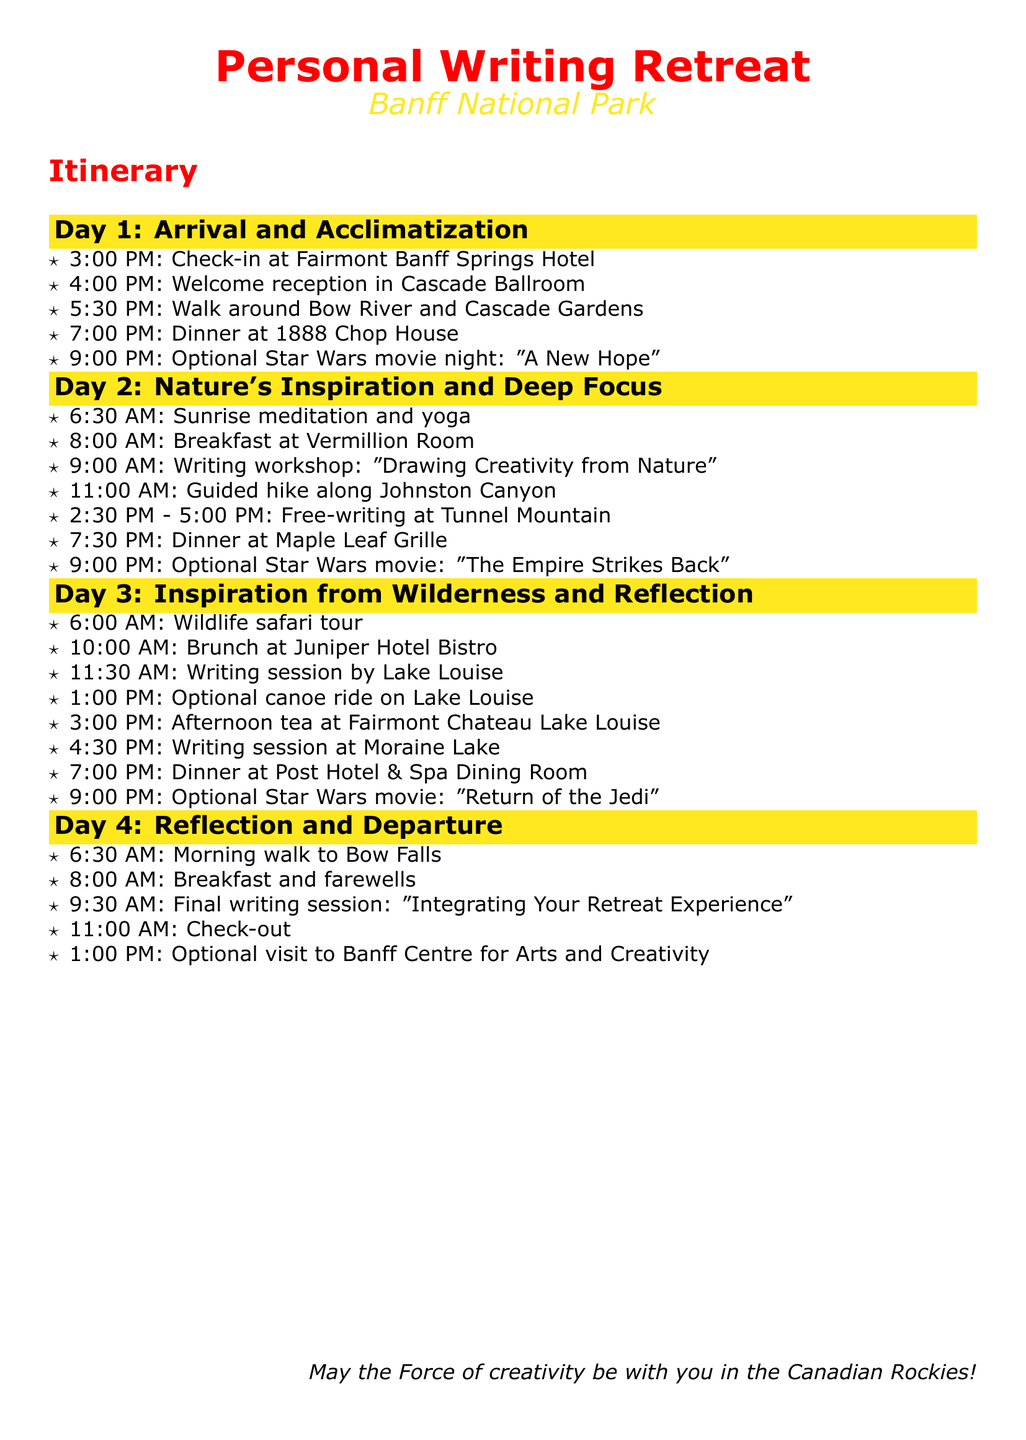What time is check-in on Day 1? Check-in is scheduled at 3:00 PM on Day 1 as mentioned in the itinerary.
Answer: 3:00 PM What is the main activity scheduled at 9:00 PM on Day 3? The main activity scheduled at 9:00 PM on Day 3 is an optional Star Wars movie night featuring "Return of the Jedi."
Answer: "Return of the Jedi" How many writing sessions are scheduled throughout the itinerary? There are four writing sessions detailed across the days in the itinerary, allowing for various creative opportunities.
Answer: 4 What is the first meal of Day 2? The first meal on Day 2 is breakfast at Vermillion Room, as indicated in the itinerary.
Answer: Breakfast at Vermillion Room What is the name of the hotel where participants will check in? Participants will check in at Fairmont Banff Springs Hotel, which is explicitly stated on Day 1.
Answer: Fairmont Banff Springs Hotel What optional activity can be done at Lake Louise? An optional activity that can be done at Lake Louise is a canoe ride, which is mentioned in the Day 3 schedule.
Answer: Canoe ride What time is the final writing session scheduled on Day 4? The final writing session on Day 4 is scheduled at 9:30 AM, as outlined in the itinerary.
Answer: 9:30 AM Which Star Wars movie is shown on Day 2? The Star Wars movie shown on Day 2 is "The Empire Strikes Back," as noted in the evening schedule.
Answer: "The Empire Strikes Back" 